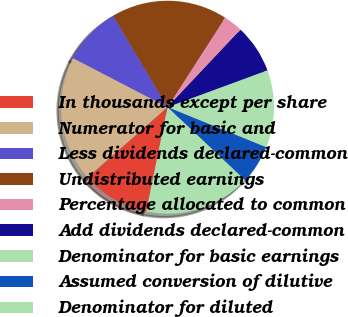Convert chart to OTSL. <chart><loc_0><loc_0><loc_500><loc_500><pie_chart><fcel>In thousands except per share<fcel>Numerator for basic and<fcel>Less dividends declared-common<fcel>Undistributed earnings<fcel>Percentage allocated to common<fcel>Add dividends declared-common<fcel>Denominator for basic earnings<fcel>Assumed conversion of dilutive<fcel>Denominator for diluted<nl><fcel>10.29%<fcel>19.12%<fcel>8.82%<fcel>17.65%<fcel>2.94%<fcel>7.35%<fcel>11.76%<fcel>5.88%<fcel>16.18%<nl></chart> 